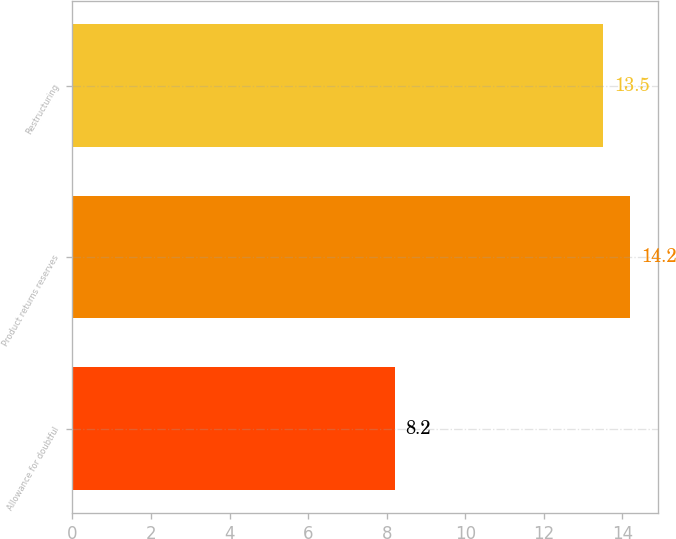Convert chart. <chart><loc_0><loc_0><loc_500><loc_500><bar_chart><fcel>Allowance for doubtful<fcel>Product returns reserves<fcel>Restructuring<nl><fcel>8.2<fcel>14.2<fcel>13.5<nl></chart> 